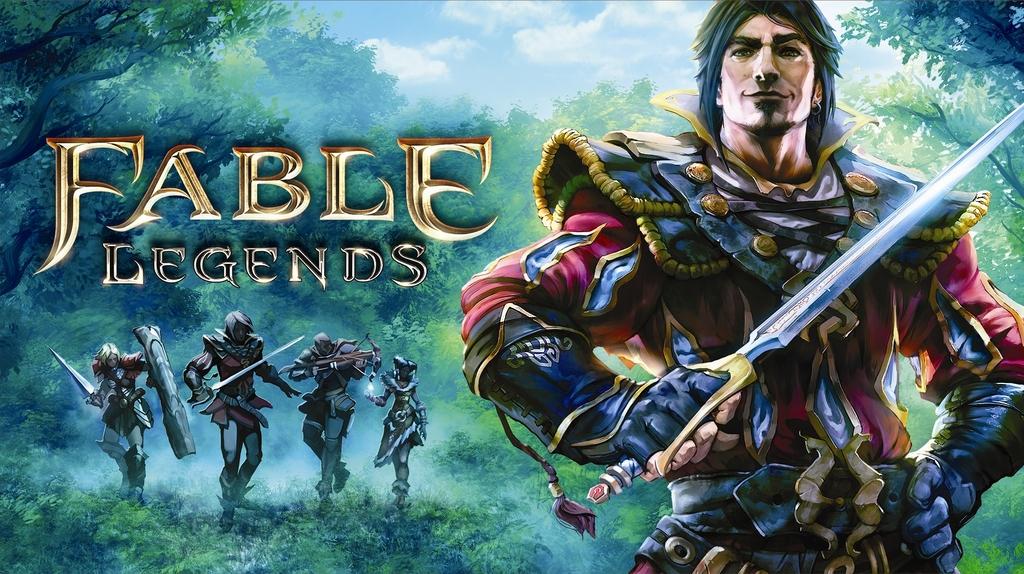What is the name of the video game this picture promotes?
Provide a short and direct response. Fable legends. 